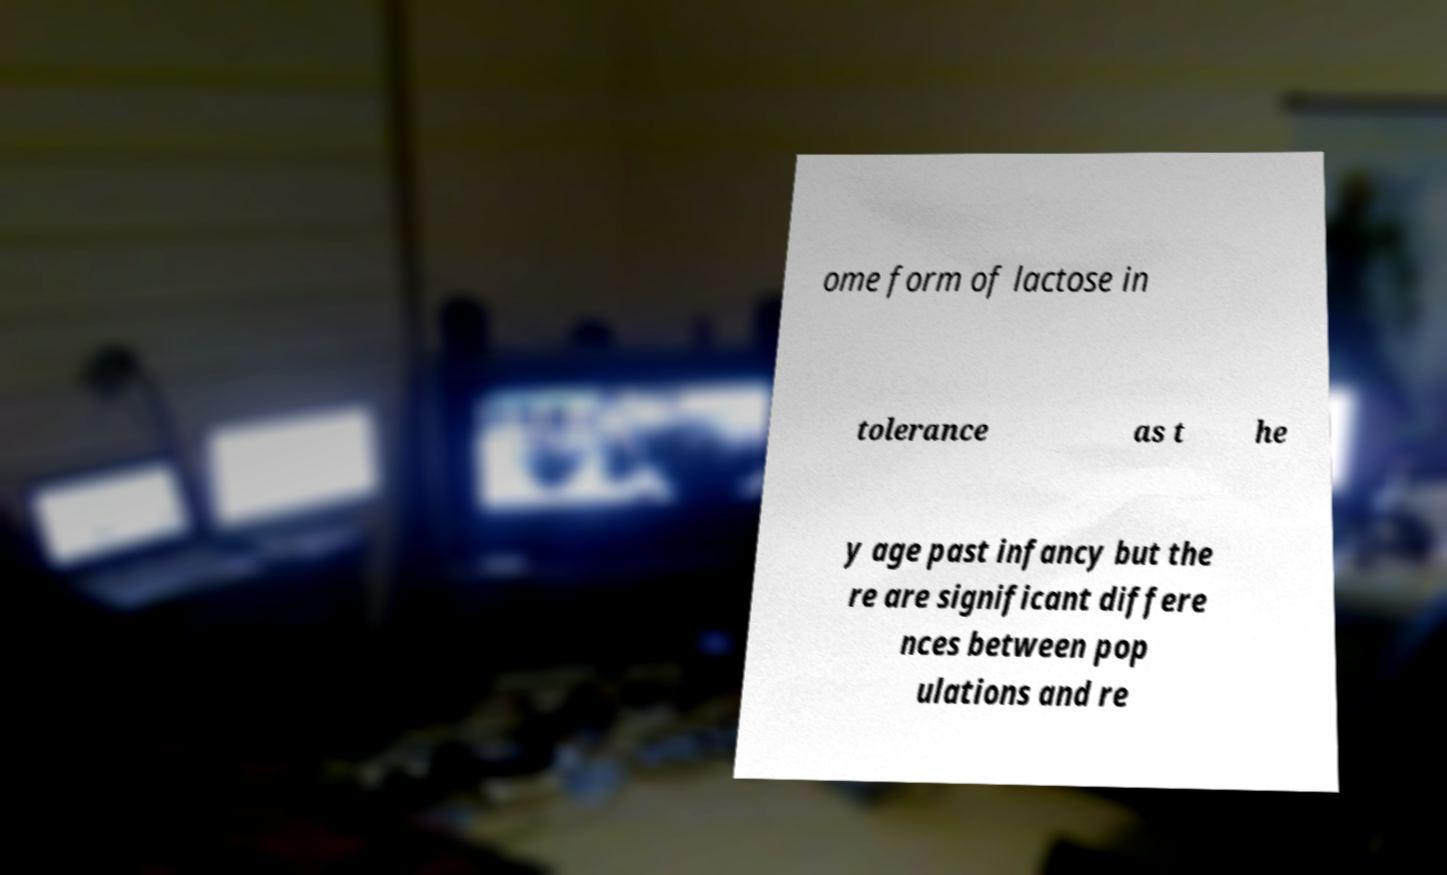For documentation purposes, I need the text within this image transcribed. Could you provide that? ome form of lactose in tolerance as t he y age past infancy but the re are significant differe nces between pop ulations and re 